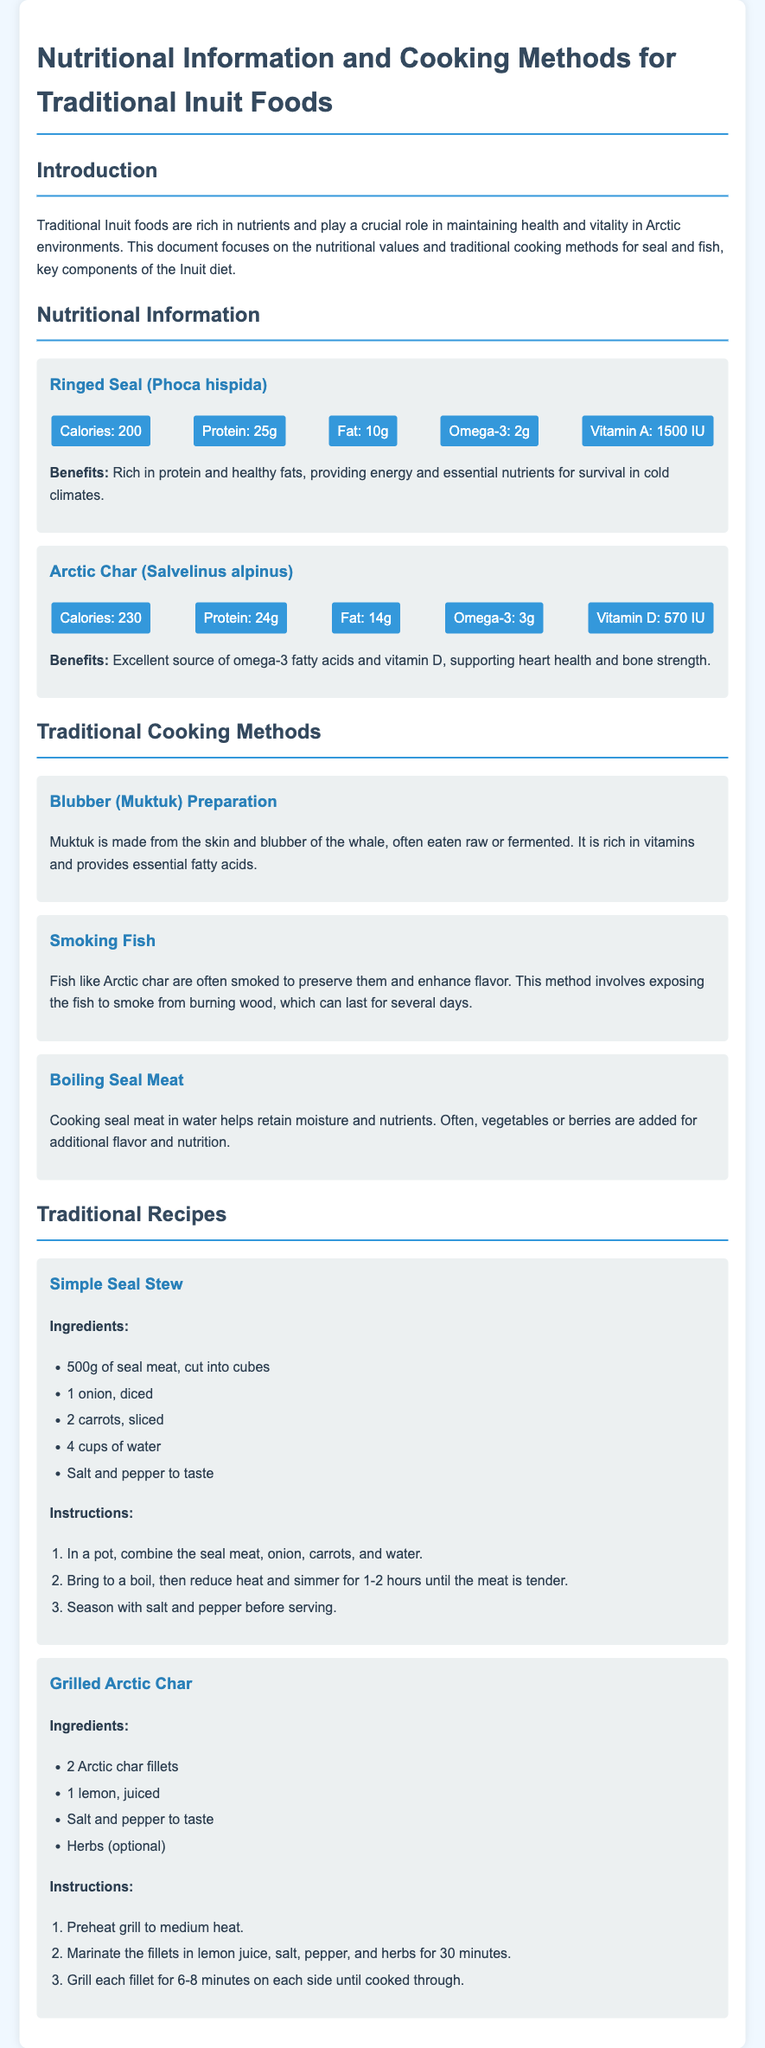What are the calories in Ringed Seal? The document states that Ringed Seal contains 200 calories.
Answer: 200 What nutritional benefit does Arctic Char provide? Arctic Char is described as an excellent source of omega-3 fatty acids and vitamin D.
Answer: Omega-3 and vitamin D What is Muktuk made from? Muktuk is made from the skin and blubber of the whale.
Answer: Skin and blubber How long should you grill Arctic Char fillets? The instruction mentions grilling each fillet for 6-8 minutes on each side.
Answer: 6-8 minutes What is the main cooking method for seal meat mentioned? The document details boiling seal meat as a primary cooking method.
Answer: Boiling How many ingredients are listed for Simple Seal Stew? The ingredients for Simple Seal Stew total five items.
Answer: Five Which fish is often smoked for preservation? The document mentions that Arctic Char is often smoked.
Answer: Arctic Char What is the suggested cooking time for the Simple Seal Stew? The stew is suggested to simmer for 1-2 hours until the meat is tender.
Answer: 1-2 hours 